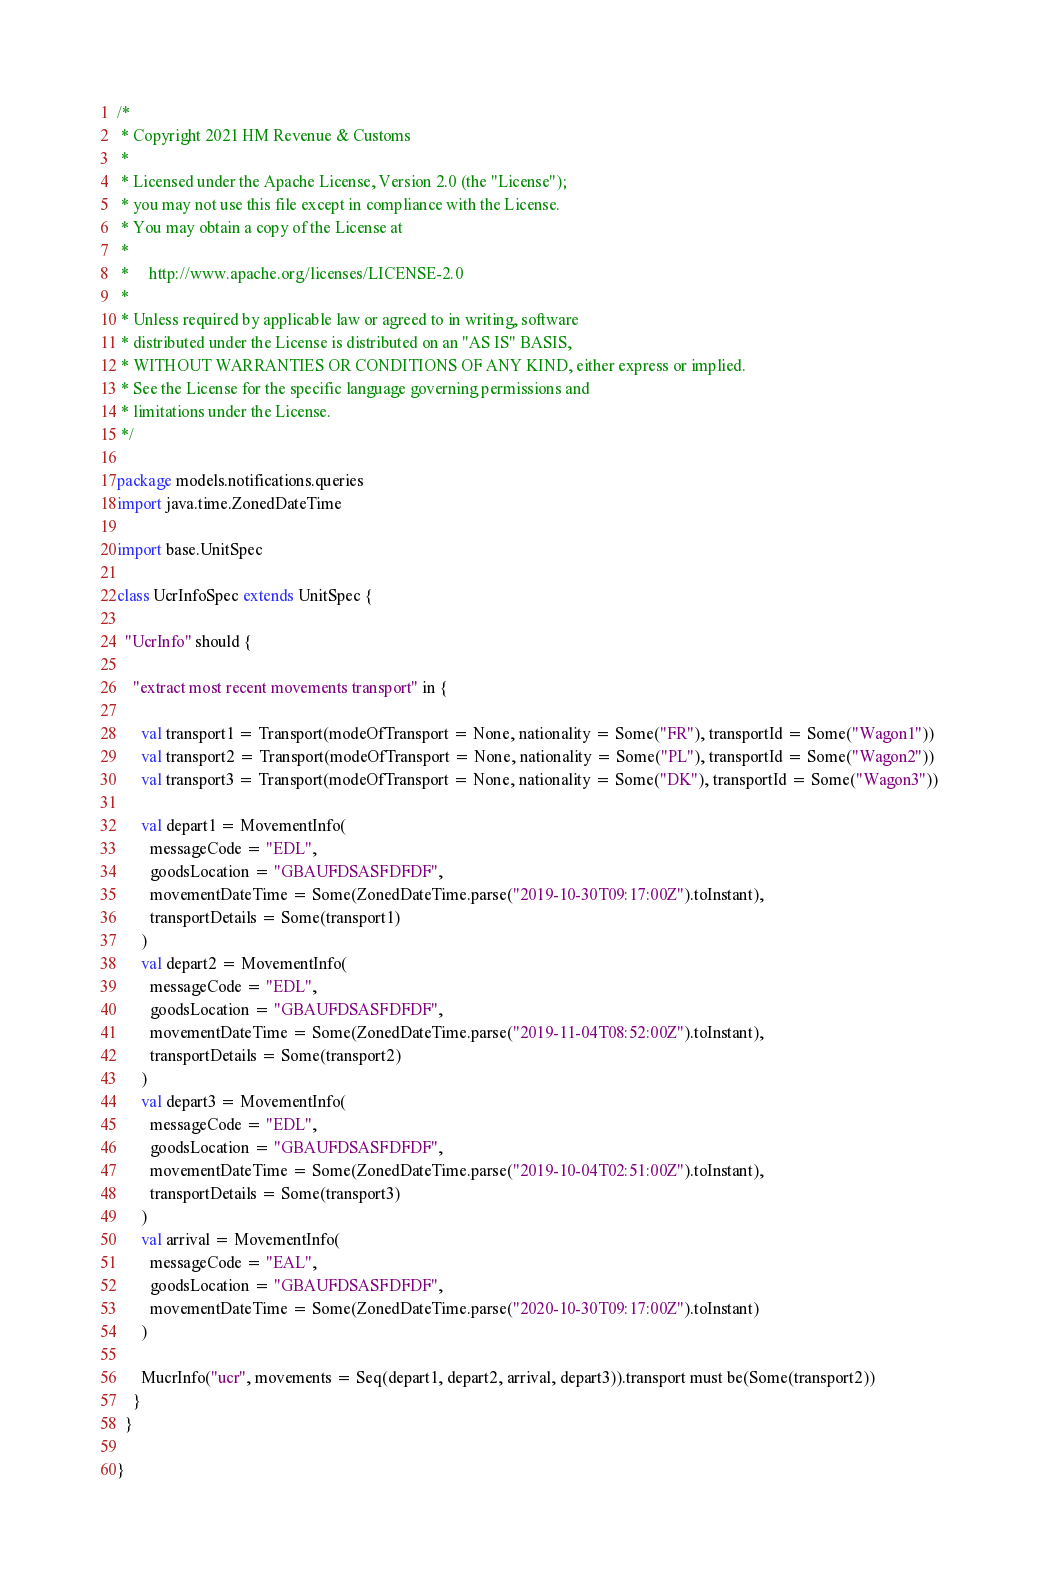Convert code to text. <code><loc_0><loc_0><loc_500><loc_500><_Scala_>/*
 * Copyright 2021 HM Revenue & Customs
 *
 * Licensed under the Apache License, Version 2.0 (the "License");
 * you may not use this file except in compliance with the License.
 * You may obtain a copy of the License at
 *
 *     http://www.apache.org/licenses/LICENSE-2.0
 *
 * Unless required by applicable law or agreed to in writing, software
 * distributed under the License is distributed on an "AS IS" BASIS,
 * WITHOUT WARRANTIES OR CONDITIONS OF ANY KIND, either express or implied.
 * See the License for the specific language governing permissions and
 * limitations under the License.
 */

package models.notifications.queries
import java.time.ZonedDateTime

import base.UnitSpec

class UcrInfoSpec extends UnitSpec {

  "UcrInfo" should {

    "extract most recent movements transport" in {

      val transport1 = Transport(modeOfTransport = None, nationality = Some("FR"), transportId = Some("Wagon1"))
      val transport2 = Transport(modeOfTransport = None, nationality = Some("PL"), transportId = Some("Wagon2"))
      val transport3 = Transport(modeOfTransport = None, nationality = Some("DK"), transportId = Some("Wagon3"))

      val depart1 = MovementInfo(
        messageCode = "EDL",
        goodsLocation = "GBAUFDSASFDFDF",
        movementDateTime = Some(ZonedDateTime.parse("2019-10-30T09:17:00Z").toInstant),
        transportDetails = Some(transport1)
      )
      val depart2 = MovementInfo(
        messageCode = "EDL",
        goodsLocation = "GBAUFDSASFDFDF",
        movementDateTime = Some(ZonedDateTime.parse("2019-11-04T08:52:00Z").toInstant),
        transportDetails = Some(transport2)
      )
      val depart3 = MovementInfo(
        messageCode = "EDL",
        goodsLocation = "GBAUFDSASFDFDF",
        movementDateTime = Some(ZonedDateTime.parse("2019-10-04T02:51:00Z").toInstant),
        transportDetails = Some(transport3)
      )
      val arrival = MovementInfo(
        messageCode = "EAL",
        goodsLocation = "GBAUFDSASFDFDF",
        movementDateTime = Some(ZonedDateTime.parse("2020-10-30T09:17:00Z").toInstant)
      )

      MucrInfo("ucr", movements = Seq(depart1, depart2, arrival, depart3)).transport must be(Some(transport2))
    }
  }

}
</code> 